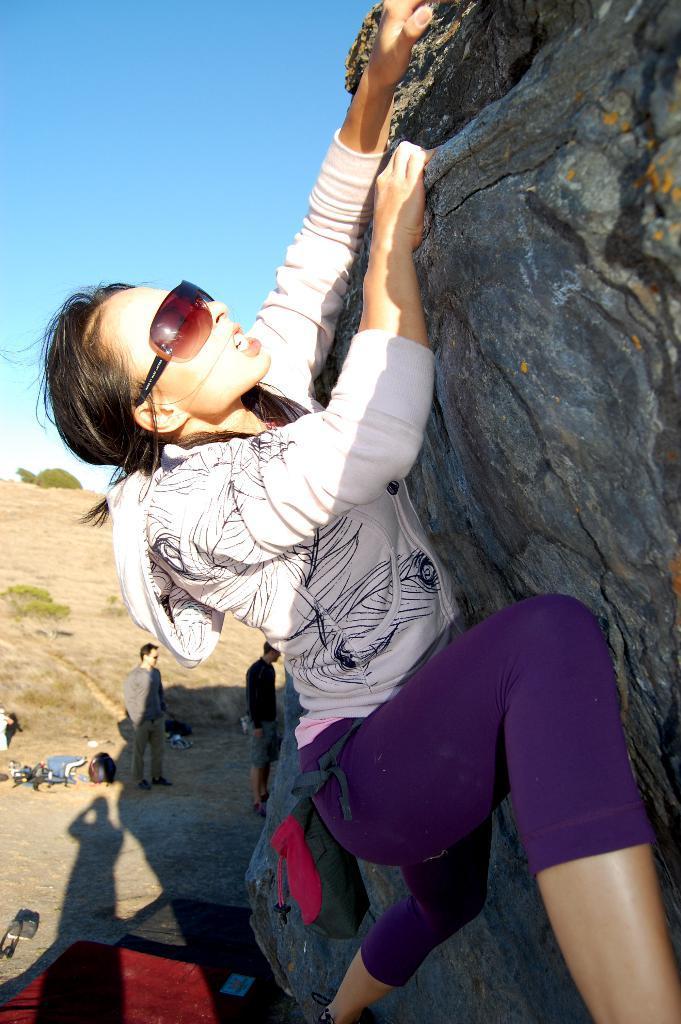Please provide a concise description of this image. In the image we can see a woman wearing clothes, goggles and the woman is climbing the rock. We can see there are even other people standing and wearing clothes. Here we can see the plant and the sky. 